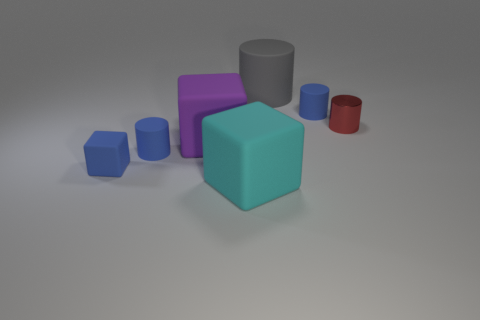Add 2 matte cubes. How many objects exist? 9 Subtract all large blocks. How many blocks are left? 1 Subtract all green balls. How many blue cylinders are left? 2 Subtract all gray cylinders. How many cylinders are left? 3 Subtract 1 cubes. How many cubes are left? 2 Add 5 purple things. How many purple things are left? 6 Add 6 cubes. How many cubes exist? 9 Subtract 0 brown spheres. How many objects are left? 7 Subtract all cylinders. How many objects are left? 3 Subtract all brown cylinders. Subtract all purple blocks. How many cylinders are left? 4 